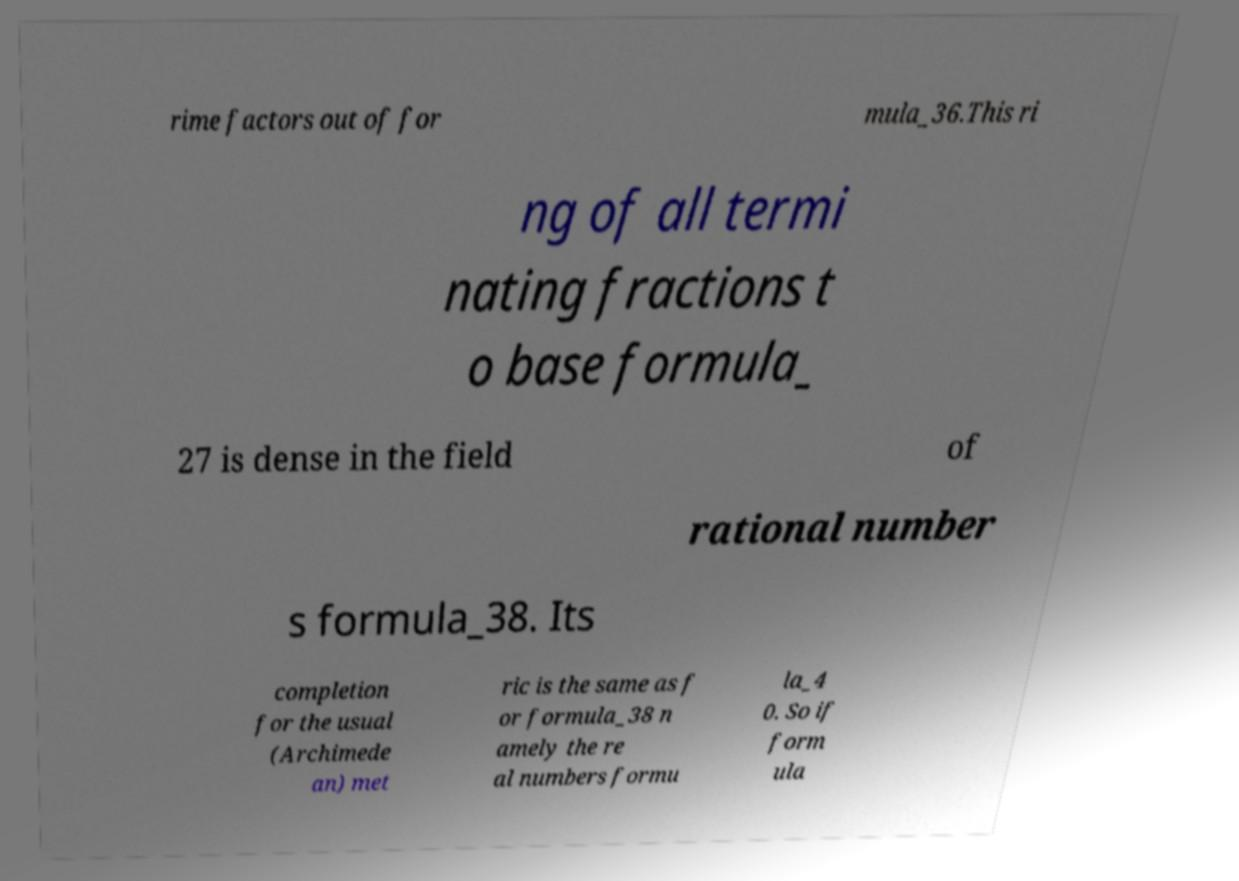There's text embedded in this image that I need extracted. Can you transcribe it verbatim? rime factors out of for mula_36.This ri ng of all termi nating fractions t o base formula_ 27 is dense in the field of rational number s formula_38. Its completion for the usual (Archimede an) met ric is the same as f or formula_38 n amely the re al numbers formu la_4 0. So if form ula 